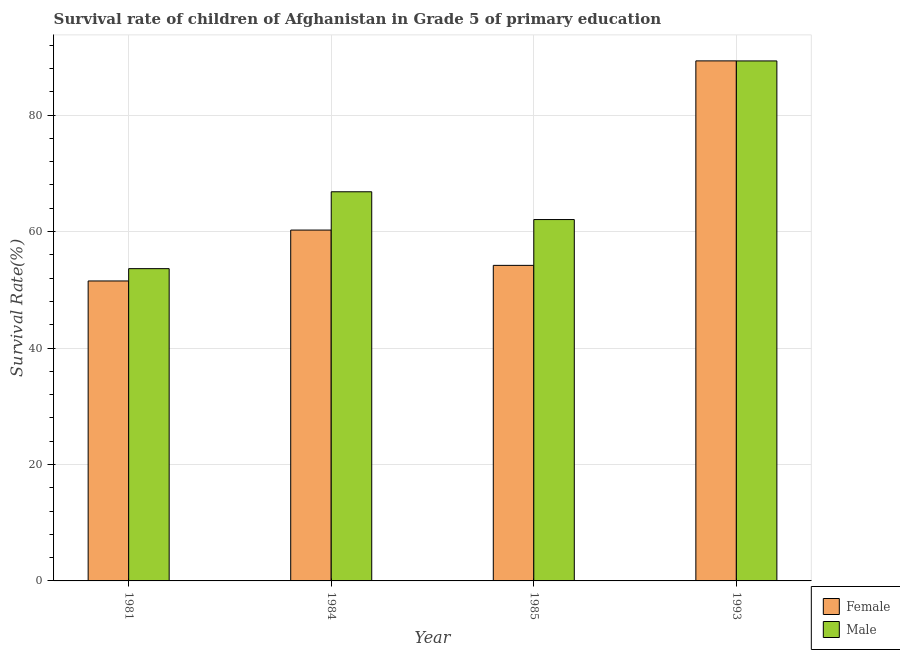Are the number of bars per tick equal to the number of legend labels?
Make the answer very short. Yes. Are the number of bars on each tick of the X-axis equal?
Offer a very short reply. Yes. In how many cases, is the number of bars for a given year not equal to the number of legend labels?
Make the answer very short. 0. What is the survival rate of male students in primary education in 1993?
Keep it short and to the point. 89.31. Across all years, what is the maximum survival rate of female students in primary education?
Ensure brevity in your answer.  89.32. Across all years, what is the minimum survival rate of male students in primary education?
Offer a very short reply. 53.63. In which year was the survival rate of male students in primary education minimum?
Offer a very short reply. 1981. What is the total survival rate of male students in primary education in the graph?
Offer a very short reply. 271.84. What is the difference between the survival rate of male students in primary education in 1984 and that in 1993?
Provide a succinct answer. -22.47. What is the difference between the survival rate of female students in primary education in 1984 and the survival rate of male students in primary education in 1981?
Keep it short and to the point. 8.74. What is the average survival rate of female students in primary education per year?
Offer a very short reply. 63.82. In the year 1993, what is the difference between the survival rate of male students in primary education and survival rate of female students in primary education?
Your response must be concise. 0. What is the ratio of the survival rate of female students in primary education in 1985 to that in 1993?
Your answer should be very brief. 0.61. What is the difference between the highest and the second highest survival rate of female students in primary education?
Make the answer very short. 29.06. What is the difference between the highest and the lowest survival rate of male students in primary education?
Make the answer very short. 35.68. How many bars are there?
Your answer should be very brief. 8. What is the difference between two consecutive major ticks on the Y-axis?
Your answer should be very brief. 20. Are the values on the major ticks of Y-axis written in scientific E-notation?
Provide a short and direct response. No. Does the graph contain any zero values?
Provide a short and direct response. No. Where does the legend appear in the graph?
Make the answer very short. Bottom right. How are the legend labels stacked?
Provide a short and direct response. Vertical. What is the title of the graph?
Your response must be concise. Survival rate of children of Afghanistan in Grade 5 of primary education. Does "Not attending school" appear as one of the legend labels in the graph?
Make the answer very short. No. What is the label or title of the X-axis?
Provide a succinct answer. Year. What is the label or title of the Y-axis?
Make the answer very short. Survival Rate(%). What is the Survival Rate(%) of Female in 1981?
Provide a succinct answer. 51.52. What is the Survival Rate(%) in Male in 1981?
Your answer should be very brief. 53.63. What is the Survival Rate(%) in Female in 1984?
Provide a short and direct response. 60.26. What is the Survival Rate(%) of Male in 1984?
Your answer should be compact. 66.84. What is the Survival Rate(%) of Female in 1985?
Provide a succinct answer. 54.2. What is the Survival Rate(%) of Male in 1985?
Your answer should be compact. 62.06. What is the Survival Rate(%) of Female in 1993?
Your answer should be very brief. 89.32. What is the Survival Rate(%) of Male in 1993?
Your answer should be compact. 89.31. Across all years, what is the maximum Survival Rate(%) of Female?
Provide a succinct answer. 89.32. Across all years, what is the maximum Survival Rate(%) in Male?
Your answer should be compact. 89.31. Across all years, what is the minimum Survival Rate(%) in Female?
Keep it short and to the point. 51.52. Across all years, what is the minimum Survival Rate(%) of Male?
Keep it short and to the point. 53.63. What is the total Survival Rate(%) of Female in the graph?
Give a very brief answer. 255.29. What is the total Survival Rate(%) in Male in the graph?
Keep it short and to the point. 271.84. What is the difference between the Survival Rate(%) of Female in 1981 and that in 1984?
Provide a succinct answer. -8.74. What is the difference between the Survival Rate(%) of Male in 1981 and that in 1984?
Your response must be concise. -13.2. What is the difference between the Survival Rate(%) in Female in 1981 and that in 1985?
Make the answer very short. -2.68. What is the difference between the Survival Rate(%) in Male in 1981 and that in 1985?
Provide a short and direct response. -8.43. What is the difference between the Survival Rate(%) in Female in 1981 and that in 1993?
Provide a succinct answer. -37.8. What is the difference between the Survival Rate(%) in Male in 1981 and that in 1993?
Keep it short and to the point. -35.68. What is the difference between the Survival Rate(%) of Female in 1984 and that in 1985?
Provide a succinct answer. 6.06. What is the difference between the Survival Rate(%) of Male in 1984 and that in 1985?
Ensure brevity in your answer.  4.77. What is the difference between the Survival Rate(%) in Female in 1984 and that in 1993?
Your answer should be very brief. -29.06. What is the difference between the Survival Rate(%) in Male in 1984 and that in 1993?
Provide a succinct answer. -22.47. What is the difference between the Survival Rate(%) in Female in 1985 and that in 1993?
Ensure brevity in your answer.  -35.12. What is the difference between the Survival Rate(%) in Male in 1985 and that in 1993?
Provide a short and direct response. -27.24. What is the difference between the Survival Rate(%) of Female in 1981 and the Survival Rate(%) of Male in 1984?
Give a very brief answer. -15.32. What is the difference between the Survival Rate(%) in Female in 1981 and the Survival Rate(%) in Male in 1985?
Keep it short and to the point. -10.55. What is the difference between the Survival Rate(%) in Female in 1981 and the Survival Rate(%) in Male in 1993?
Offer a terse response. -37.79. What is the difference between the Survival Rate(%) of Female in 1984 and the Survival Rate(%) of Male in 1985?
Your answer should be compact. -1.81. What is the difference between the Survival Rate(%) of Female in 1984 and the Survival Rate(%) of Male in 1993?
Offer a very short reply. -29.05. What is the difference between the Survival Rate(%) in Female in 1985 and the Survival Rate(%) in Male in 1993?
Your answer should be very brief. -35.11. What is the average Survival Rate(%) of Female per year?
Keep it short and to the point. 63.82. What is the average Survival Rate(%) of Male per year?
Your response must be concise. 67.96. In the year 1981, what is the difference between the Survival Rate(%) of Female and Survival Rate(%) of Male?
Ensure brevity in your answer.  -2.12. In the year 1984, what is the difference between the Survival Rate(%) in Female and Survival Rate(%) in Male?
Keep it short and to the point. -6.58. In the year 1985, what is the difference between the Survival Rate(%) in Female and Survival Rate(%) in Male?
Your answer should be very brief. -7.87. In the year 1993, what is the difference between the Survival Rate(%) in Female and Survival Rate(%) in Male?
Your answer should be compact. 0.01. What is the ratio of the Survival Rate(%) in Female in 1981 to that in 1984?
Your answer should be very brief. 0.85. What is the ratio of the Survival Rate(%) in Male in 1981 to that in 1984?
Offer a very short reply. 0.8. What is the ratio of the Survival Rate(%) of Female in 1981 to that in 1985?
Keep it short and to the point. 0.95. What is the ratio of the Survival Rate(%) of Male in 1981 to that in 1985?
Give a very brief answer. 0.86. What is the ratio of the Survival Rate(%) in Female in 1981 to that in 1993?
Your answer should be compact. 0.58. What is the ratio of the Survival Rate(%) of Male in 1981 to that in 1993?
Offer a terse response. 0.6. What is the ratio of the Survival Rate(%) in Female in 1984 to that in 1985?
Ensure brevity in your answer.  1.11. What is the ratio of the Survival Rate(%) in Male in 1984 to that in 1985?
Provide a short and direct response. 1.08. What is the ratio of the Survival Rate(%) in Female in 1984 to that in 1993?
Provide a succinct answer. 0.67. What is the ratio of the Survival Rate(%) in Male in 1984 to that in 1993?
Your response must be concise. 0.75. What is the ratio of the Survival Rate(%) of Female in 1985 to that in 1993?
Keep it short and to the point. 0.61. What is the ratio of the Survival Rate(%) of Male in 1985 to that in 1993?
Offer a terse response. 0.69. What is the difference between the highest and the second highest Survival Rate(%) in Female?
Your answer should be compact. 29.06. What is the difference between the highest and the second highest Survival Rate(%) in Male?
Your answer should be compact. 22.47. What is the difference between the highest and the lowest Survival Rate(%) in Female?
Provide a succinct answer. 37.8. What is the difference between the highest and the lowest Survival Rate(%) of Male?
Your answer should be compact. 35.68. 